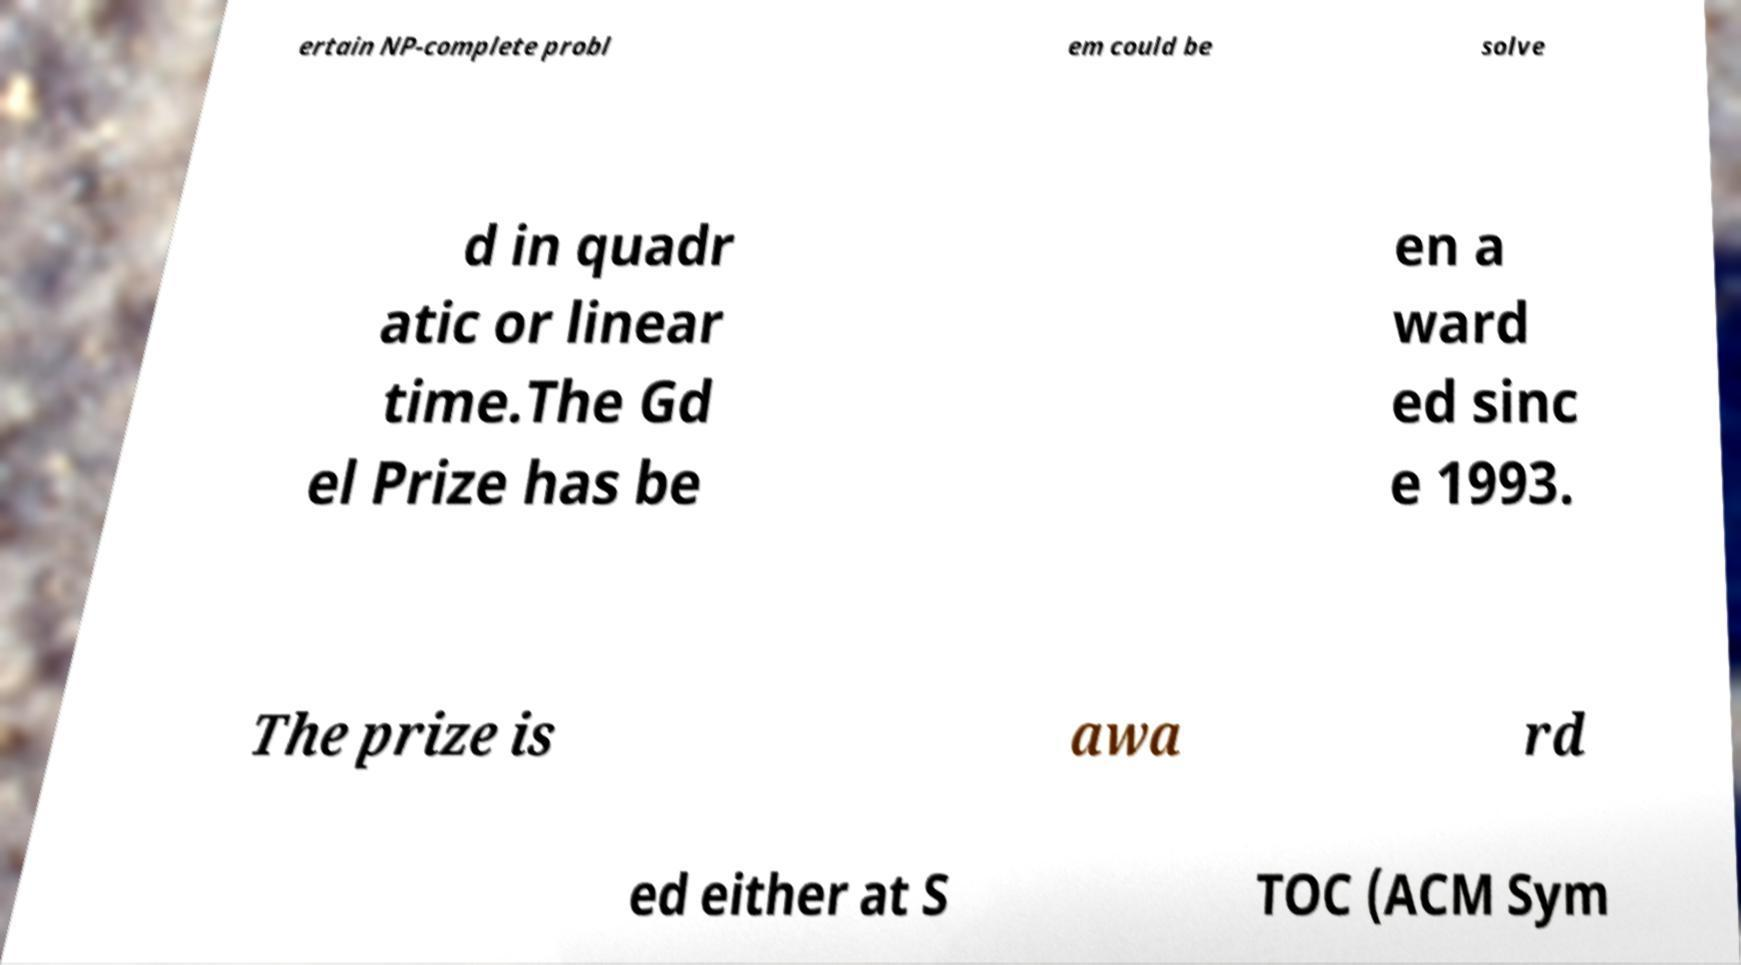There's text embedded in this image that I need extracted. Can you transcribe it verbatim? ertain NP-complete probl em could be solve d in quadr atic or linear time.The Gd el Prize has be en a ward ed sinc e 1993. The prize is awa rd ed either at S TOC (ACM Sym 